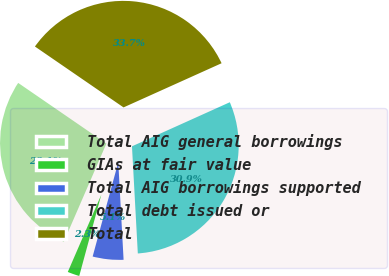Convert chart to OTSL. <chart><loc_0><loc_0><loc_500><loc_500><pie_chart><fcel>Total AIG general borrowings<fcel>GIAs at fair value<fcel>Total AIG borrowings supported<fcel>Total debt issued or<fcel>Total<nl><fcel>28.07%<fcel>2.29%<fcel>5.09%<fcel>30.87%<fcel>33.68%<nl></chart> 